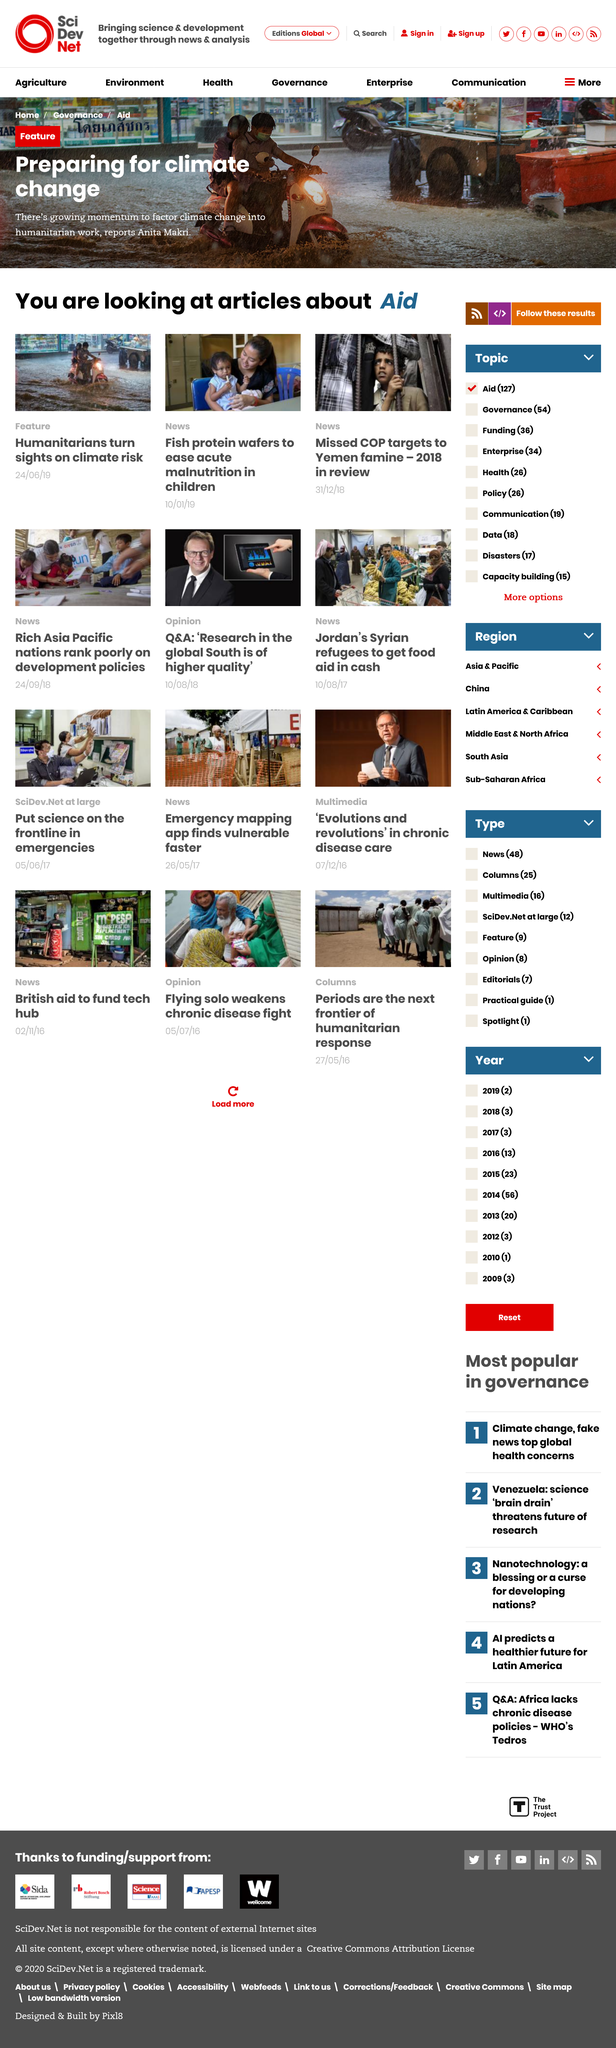Draw attention to some important aspects in this diagram. In 2018, Yemen experienced a famine. Climate risk is the target of humanitarians. We are proud to announce that our newly developed protein wafers, made from the protein of a specific creature, have been proven effective in treating acute malnutrition in children. These wafers, made from fish protein, offer a safe and reliable solution for children struggling with this serious condition. 